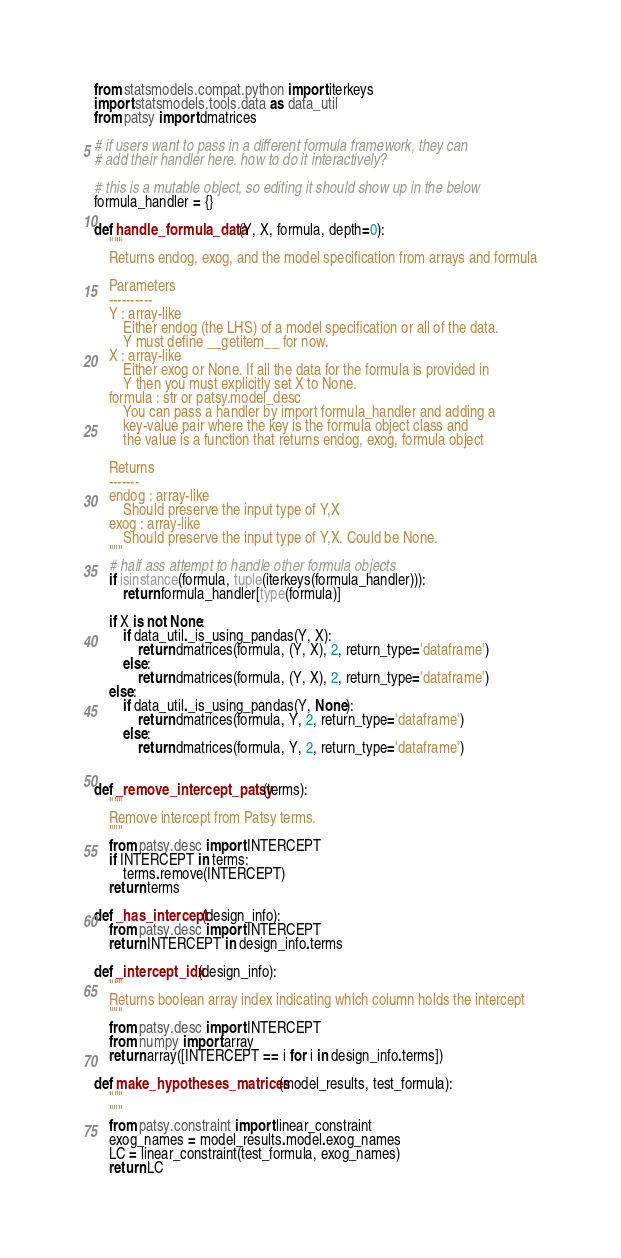Convert code to text. <code><loc_0><loc_0><loc_500><loc_500><_Python_>from statsmodels.compat.python import iterkeys
import statsmodels.tools.data as data_util
from patsy import dmatrices

# if users want to pass in a different formula framework, they can
# add their handler here. how to do it interactively?

# this is a mutable object, so editing it should show up in the below
formula_handler = {}

def handle_formula_data(Y, X, formula, depth=0):
    """
    Returns endog, exog, and the model specification from arrays and formula

    Parameters
    ----------
    Y : array-like
        Either endog (the LHS) of a model specification or all of the data.
        Y must define __getitem__ for now.
    X : array-like
        Either exog or None. If all the data for the formula is provided in
        Y then you must explicitly set X to None.
    formula : str or patsy.model_desc
        You can pass a handler by import formula_handler and adding a
        key-value pair where the key is the formula object class and
        the value is a function that returns endog, exog, formula object

    Returns
    -------
    endog : array-like
        Should preserve the input type of Y,X
    exog : array-like
        Should preserve the input type of Y,X. Could be None.
    """
    # half ass attempt to handle other formula objects
    if isinstance(formula, tuple(iterkeys(formula_handler))):
        return formula_handler[type(formula)]

    if X is not None:
        if data_util._is_using_pandas(Y, X):
            return dmatrices(formula, (Y, X), 2, return_type='dataframe')
        else:
            return dmatrices(formula, (Y, X), 2, return_type='dataframe')
    else:
        if data_util._is_using_pandas(Y, None):
            return dmatrices(formula, Y, 2, return_type='dataframe')
        else:
            return dmatrices(formula, Y, 2, return_type='dataframe')


def _remove_intercept_patsy(terms):
    """
    Remove intercept from Patsy terms.
    """
    from patsy.desc import INTERCEPT
    if INTERCEPT in terms:
        terms.remove(INTERCEPT)
    return terms

def _has_intercept(design_info):
    from patsy.desc import INTERCEPT
    return INTERCEPT in design_info.terms

def _intercept_idx(design_info):
    """
    Returns boolean array index indicating which column holds the intercept
    """
    from patsy.desc import INTERCEPT
    from numpy import array
    return array([INTERCEPT == i for i in design_info.terms])

def make_hypotheses_matrices(model_results, test_formula):
    """
    """
    from patsy.constraint import linear_constraint
    exog_names = model_results.model.exog_names
    LC = linear_constraint(test_formula, exog_names)
    return LC
</code> 